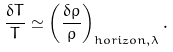<formula> <loc_0><loc_0><loc_500><loc_500>\frac { \delta T } { T } \simeq \left ( \frac { \delta \rho } { \rho } \right ) _ { h o r i z o n , \lambda } .</formula> 